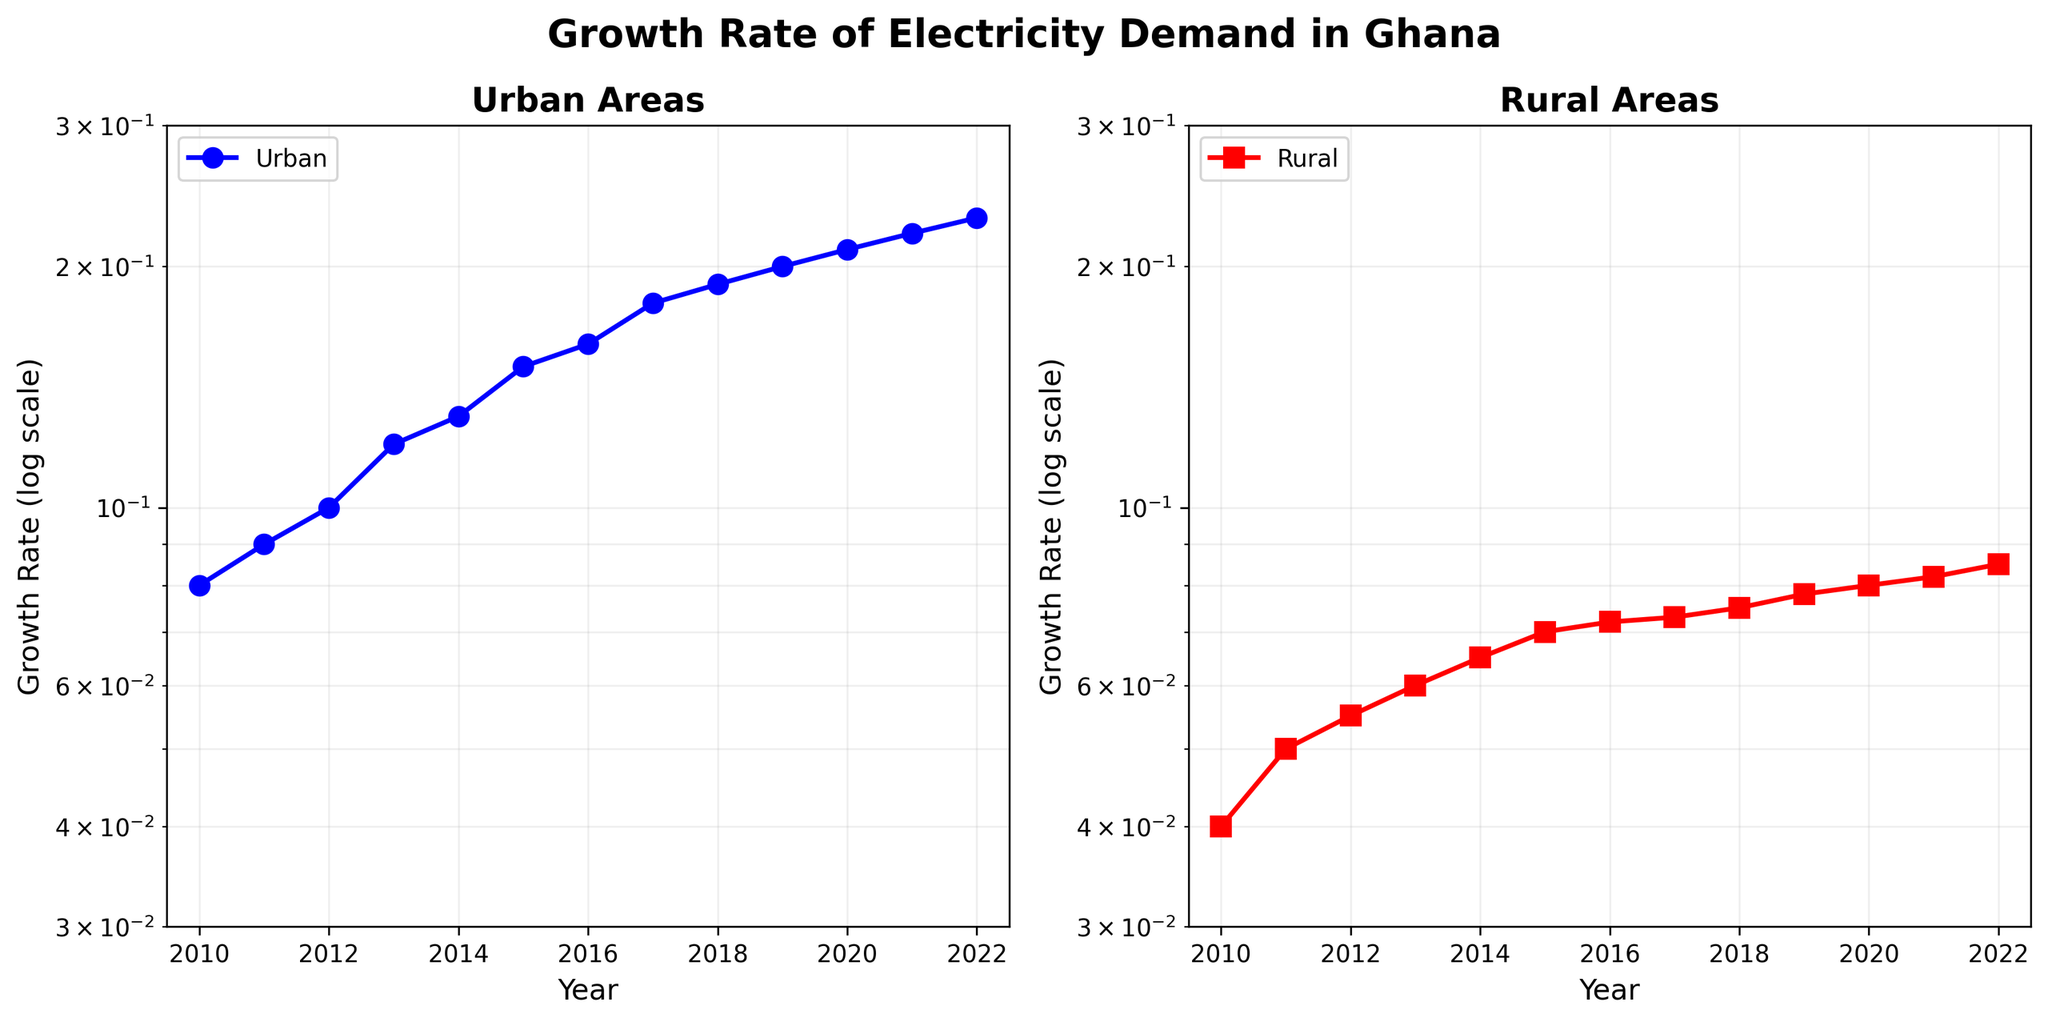What is the title of the figure? The title is placed at the top center of the figure and contains descriptive text about the plots.
Answer: Growth Rate of Electricity Demand in Ghana Which plot shows the growth rate in rural areas? There are two plots, one labeled 'Urban Areas' and one labeled 'Rural Areas'. The plot labeled 'Rural Areas' shows the growth rate in rural areas.
Answer: The plot on the right How does the growth rate change in urban areas from 2010 to 2022? By observing the plot on the left (Urban Areas), the blue line shows a general increasing trend from 0.08 to 0.23 between 2010 and 2022.
Answer: It increases from 0.08 to 0.23 What is the growth rate in rural areas for the year 2015? On the right plot (Rural Areas), locate the year 2015 on the x-axis and follow it up to the red line, which corresponds to a growth rate of 0.07.
Answer: 0.07 Compare the growth rates in urban areas and rural areas for the year 2020. For urban areas (left plot) in 2020, the rate is 0.21. For rural areas (right plot) in 2020, the rate is 0.08. Comparing these, the growth rate in urban areas is higher.
Answer: Urban 0.21, Rural 0.08 In which year does the urban growth rate first surpass 0.1? On the urban plot (left), follow the blue line to see where it exceeds 0.1. This occurs in 2012.
Answer: 2012 What is the difference in growth rates between urban and rural areas in 2017? In 2017, the urban growth rate is 0.18 and the rural growth rate is 0.073. Calculating the difference: 0.18 - 0.073 = 0.107.
Answer: 0.107 Which area, urban or rural, shows a steeper increasing trend in growth rates over the years? By comparing the slopes of the lines in the two plots, the urban area line (left) is steeper than the rural area line (right), indicating a faster increase in growth rates.
Answer: Urban What is the average annual growth rate in urban areas over the 13 years? Adding the urban growth rates and dividing by 13: (0.08 + 0.09 + 0.1 + 0.12 + 0.13 + 0.15 + 0.16 + 0.18 + 0.19 + 0.2 + 0.21 + 0.22 + 0.23) / 13 ≈ 0.157.
Answer: ~0.157 Which year had the smallest growth rate in rural areas? On the rural plot (right), the smallest growth rate is at the beginning of the timeline, in 2010, with a rate of 0.04.
Answer: 2010 